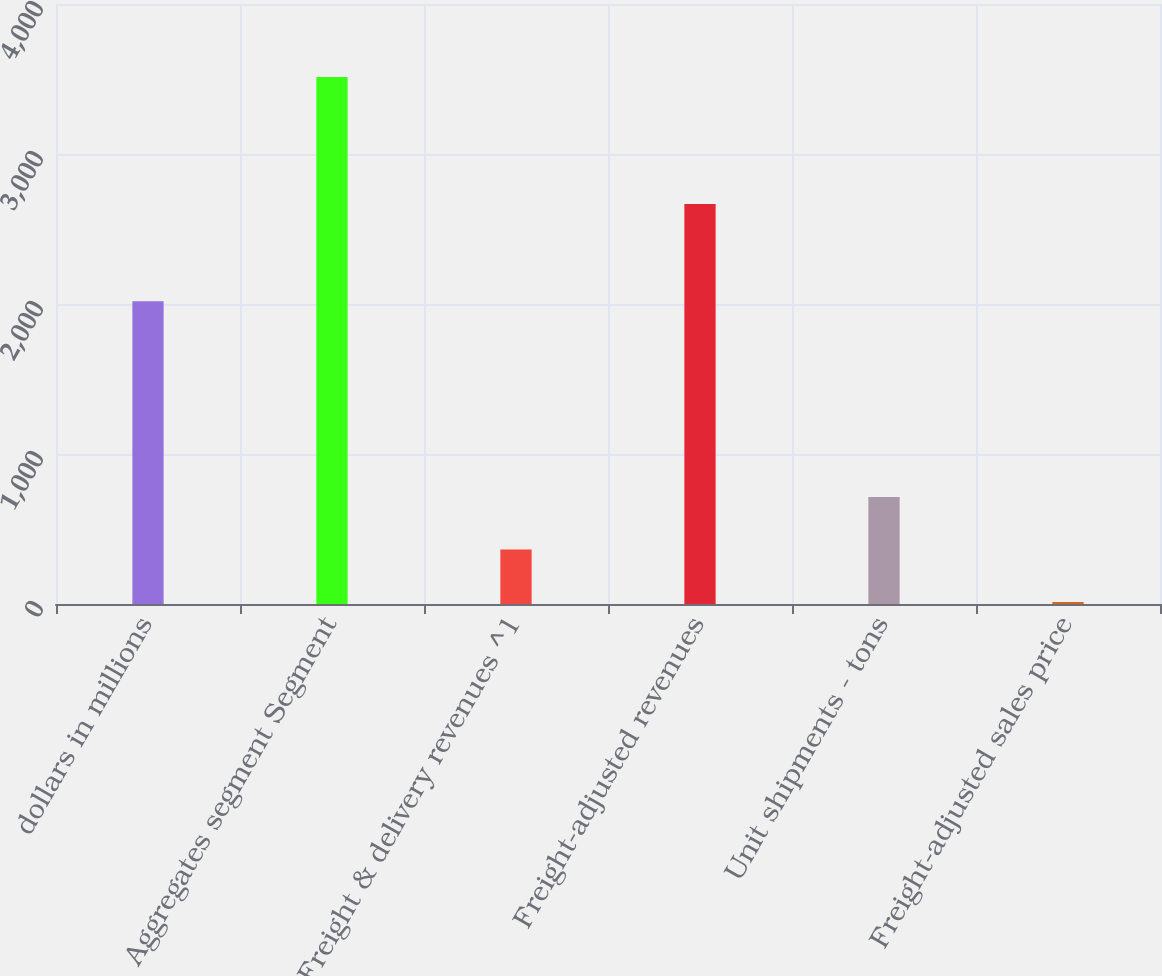Convert chart. <chart><loc_0><loc_0><loc_500><loc_500><bar_chart><fcel>dollars in millions<fcel>Aggregates segment Segment<fcel>Freight & delivery revenues ^1<fcel>Freight-adjusted revenues<fcel>Unit shipments - tons<fcel>Freight-adjusted sales price<nl><fcel>2018<fcel>3513.6<fcel>363.29<fcel>2667.3<fcel>713.33<fcel>13.25<nl></chart> 